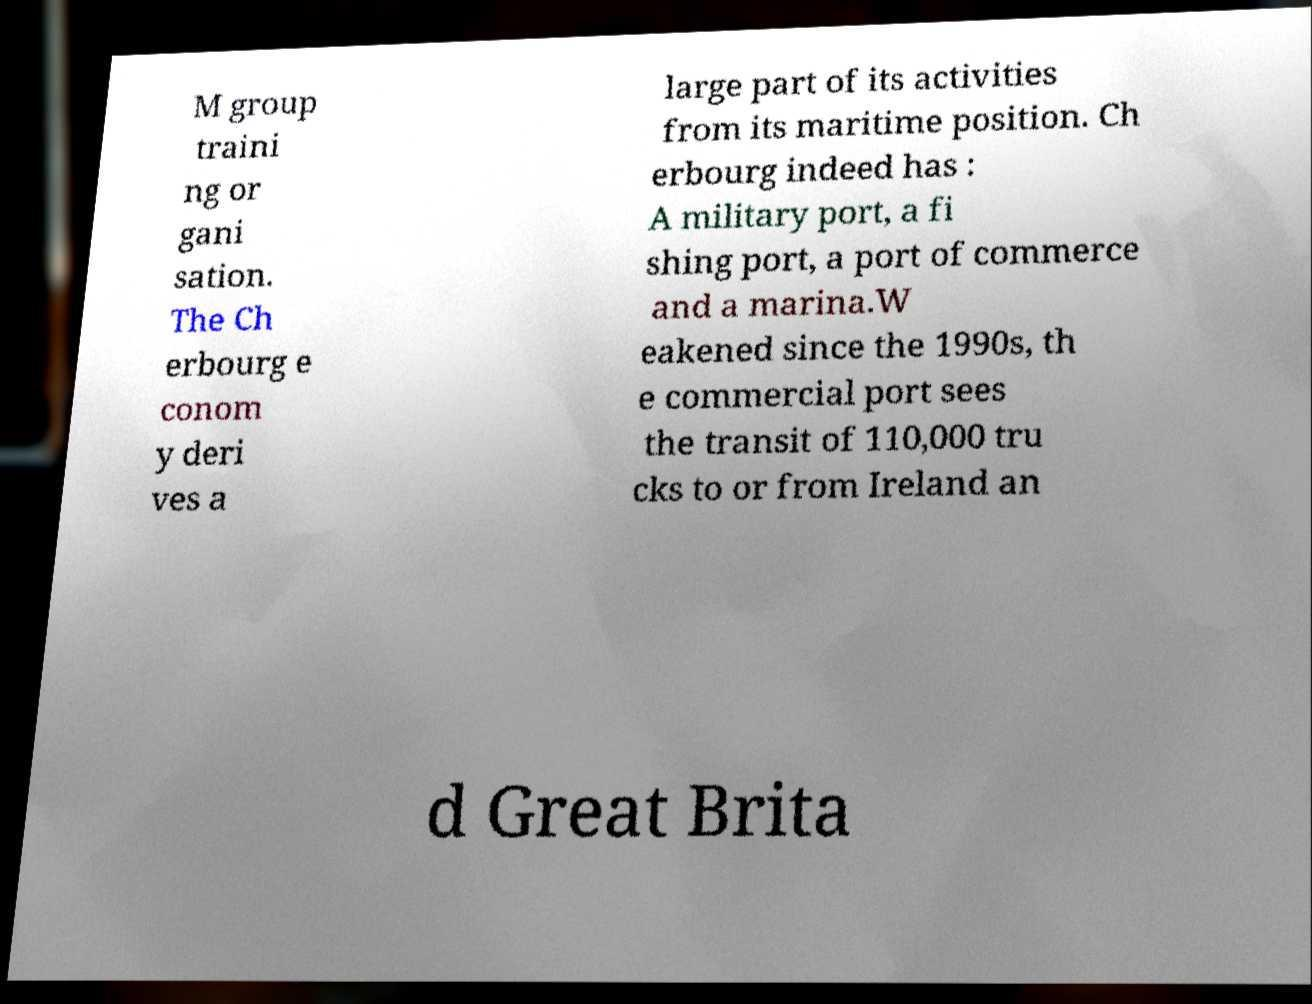Could you extract and type out the text from this image? M group traini ng or gani sation. The Ch erbourg e conom y deri ves a large part of its activities from its maritime position. Ch erbourg indeed has : A military port, a fi shing port, a port of commerce and a marina.W eakened since the 1990s, th e commercial port sees the transit of 110,000 tru cks to or from Ireland an d Great Brita 